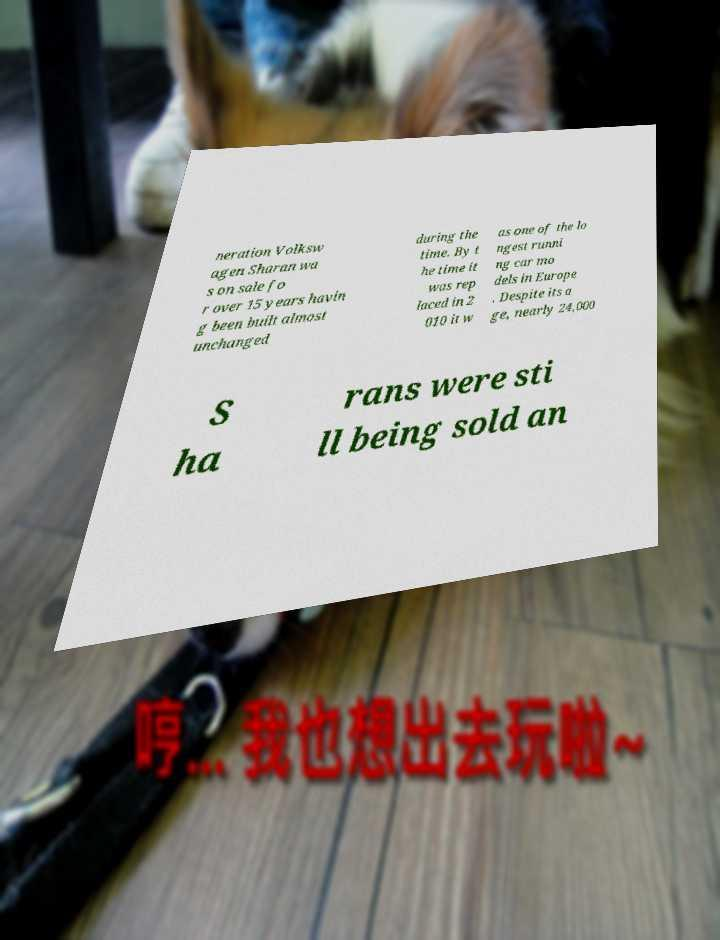Could you assist in decoding the text presented in this image and type it out clearly? neration Volksw agen Sharan wa s on sale fo r over 15 years havin g been built almost unchanged during the time. By t he time it was rep laced in 2 010 it w as one of the lo ngest runni ng car mo dels in Europe . Despite its a ge, nearly 24,000 S ha rans were sti ll being sold an 